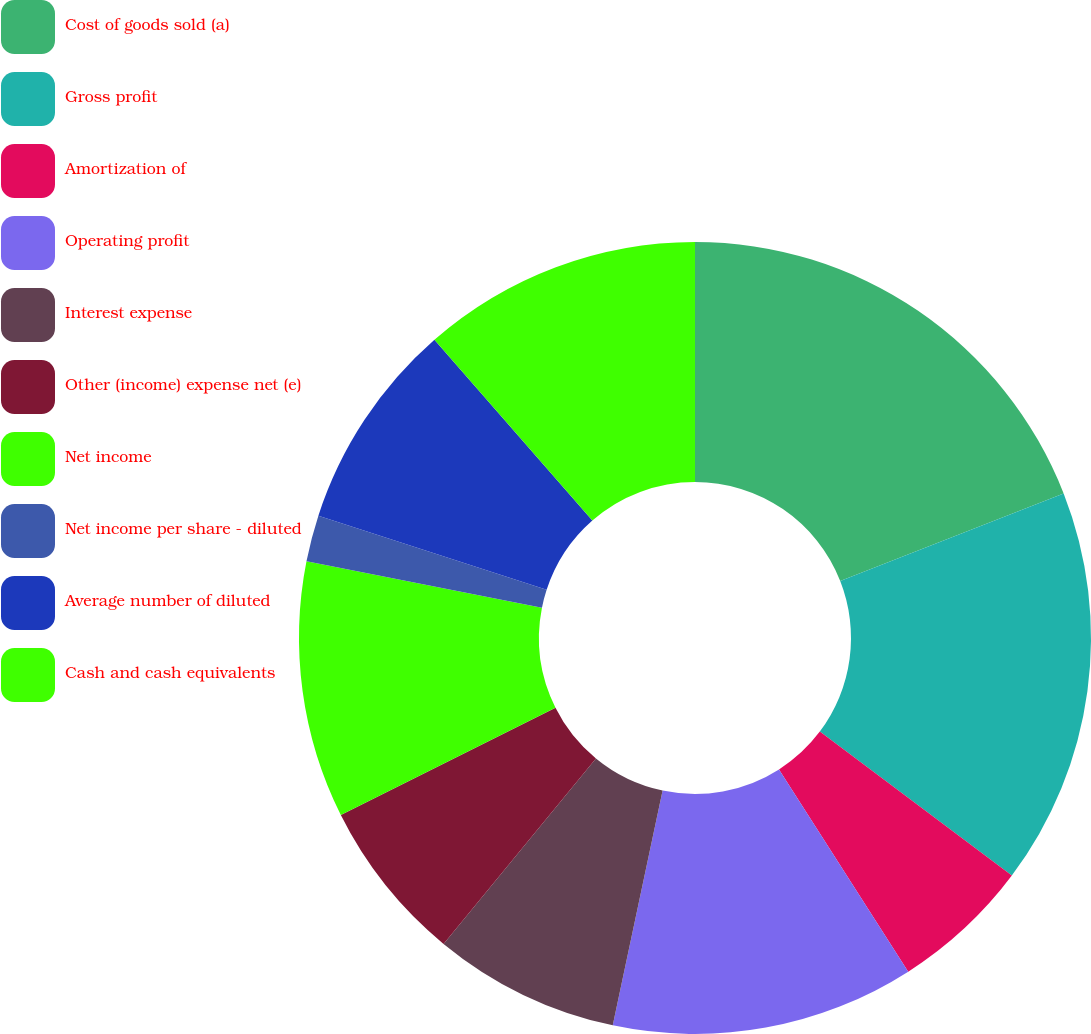Convert chart to OTSL. <chart><loc_0><loc_0><loc_500><loc_500><pie_chart><fcel>Cost of goods sold (a)<fcel>Gross profit<fcel>Amortization of<fcel>Operating profit<fcel>Interest expense<fcel>Other (income) expense net (e)<fcel>Net income<fcel>Net income per share - diluted<fcel>Average number of diluted<fcel>Cash and cash equivalents<nl><fcel>19.05%<fcel>16.19%<fcel>5.71%<fcel>12.38%<fcel>7.62%<fcel>6.67%<fcel>10.48%<fcel>1.9%<fcel>8.57%<fcel>11.43%<nl></chart> 